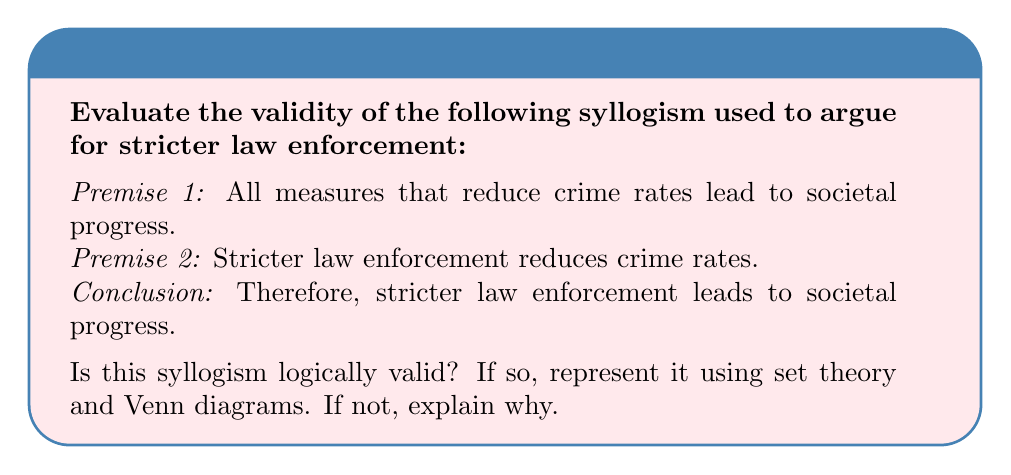Provide a solution to this math problem. To evaluate the validity of this syllogism, we'll use set theory and Venn diagrams. Let's define our sets:

A = {measures that reduce crime rates}
B = {things that lead to societal progress}
C = {stricter law enforcement}

1. Represent the premises:
   Premise 1: $A \subseteq B$ (All A is B)
   Premise 2: $C \subseteq A$ (All C is A)

2. Visualize with a Venn diagram:

[asy]
unitsize(1cm);
pair A = (0,0), B = (1,0), C = (-0.5,0);
real r = 1;
draw(circle(A,r));
draw(circle(B,r));
draw(circle(C,0.5r));
label("A",A);
label("B",B);
label("C",C);
fill(circle(C,0.5r),lightgray);
[/asy]

3. Analyze the conclusion:
   The conclusion states that $C \subseteq B$ (All C is B)

4. Evaluate validity:
   From the Venn diagram, we can see that if C is entirely within A, and A is entirely within B, then C must also be entirely within B.

5. Formal proof:
   Let $x \in C$
   Since $C \subseteq A$, $x \in A$
   Since $A \subseteq B$, $x \in B$
   Therefore, $\forall x(x \in C \implies x \in B)$, which means $C \subseteq B$

This proves that the conclusion logically follows from the premises, making the syllogism valid.
Answer: Valid 